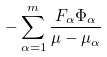<formula> <loc_0><loc_0><loc_500><loc_500>- \sum _ { \alpha = 1 } ^ { m } \frac { F _ { \alpha } \Phi _ { \alpha } } { \mu - \mu _ { \alpha } }</formula> 